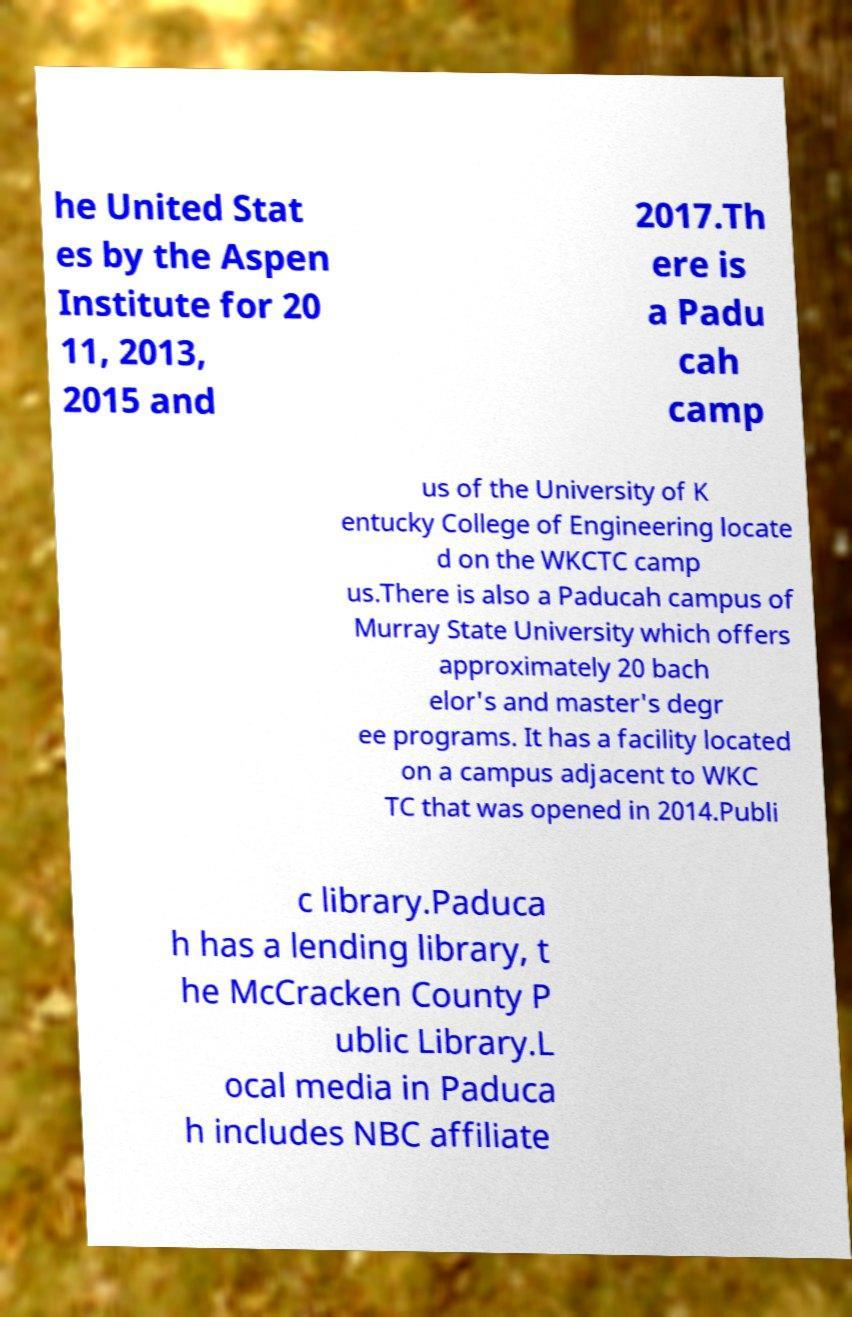I need the written content from this picture converted into text. Can you do that? he United Stat es by the Aspen Institute for 20 11, 2013, 2015 and 2017.Th ere is a Padu cah camp us of the University of K entucky College of Engineering locate d on the WKCTC camp us.There is also a Paducah campus of Murray State University which offers approximately 20 bach elor's and master's degr ee programs. It has a facility located on a campus adjacent to WKC TC that was opened in 2014.Publi c library.Paduca h has a lending library, t he McCracken County P ublic Library.L ocal media in Paduca h includes NBC affiliate 